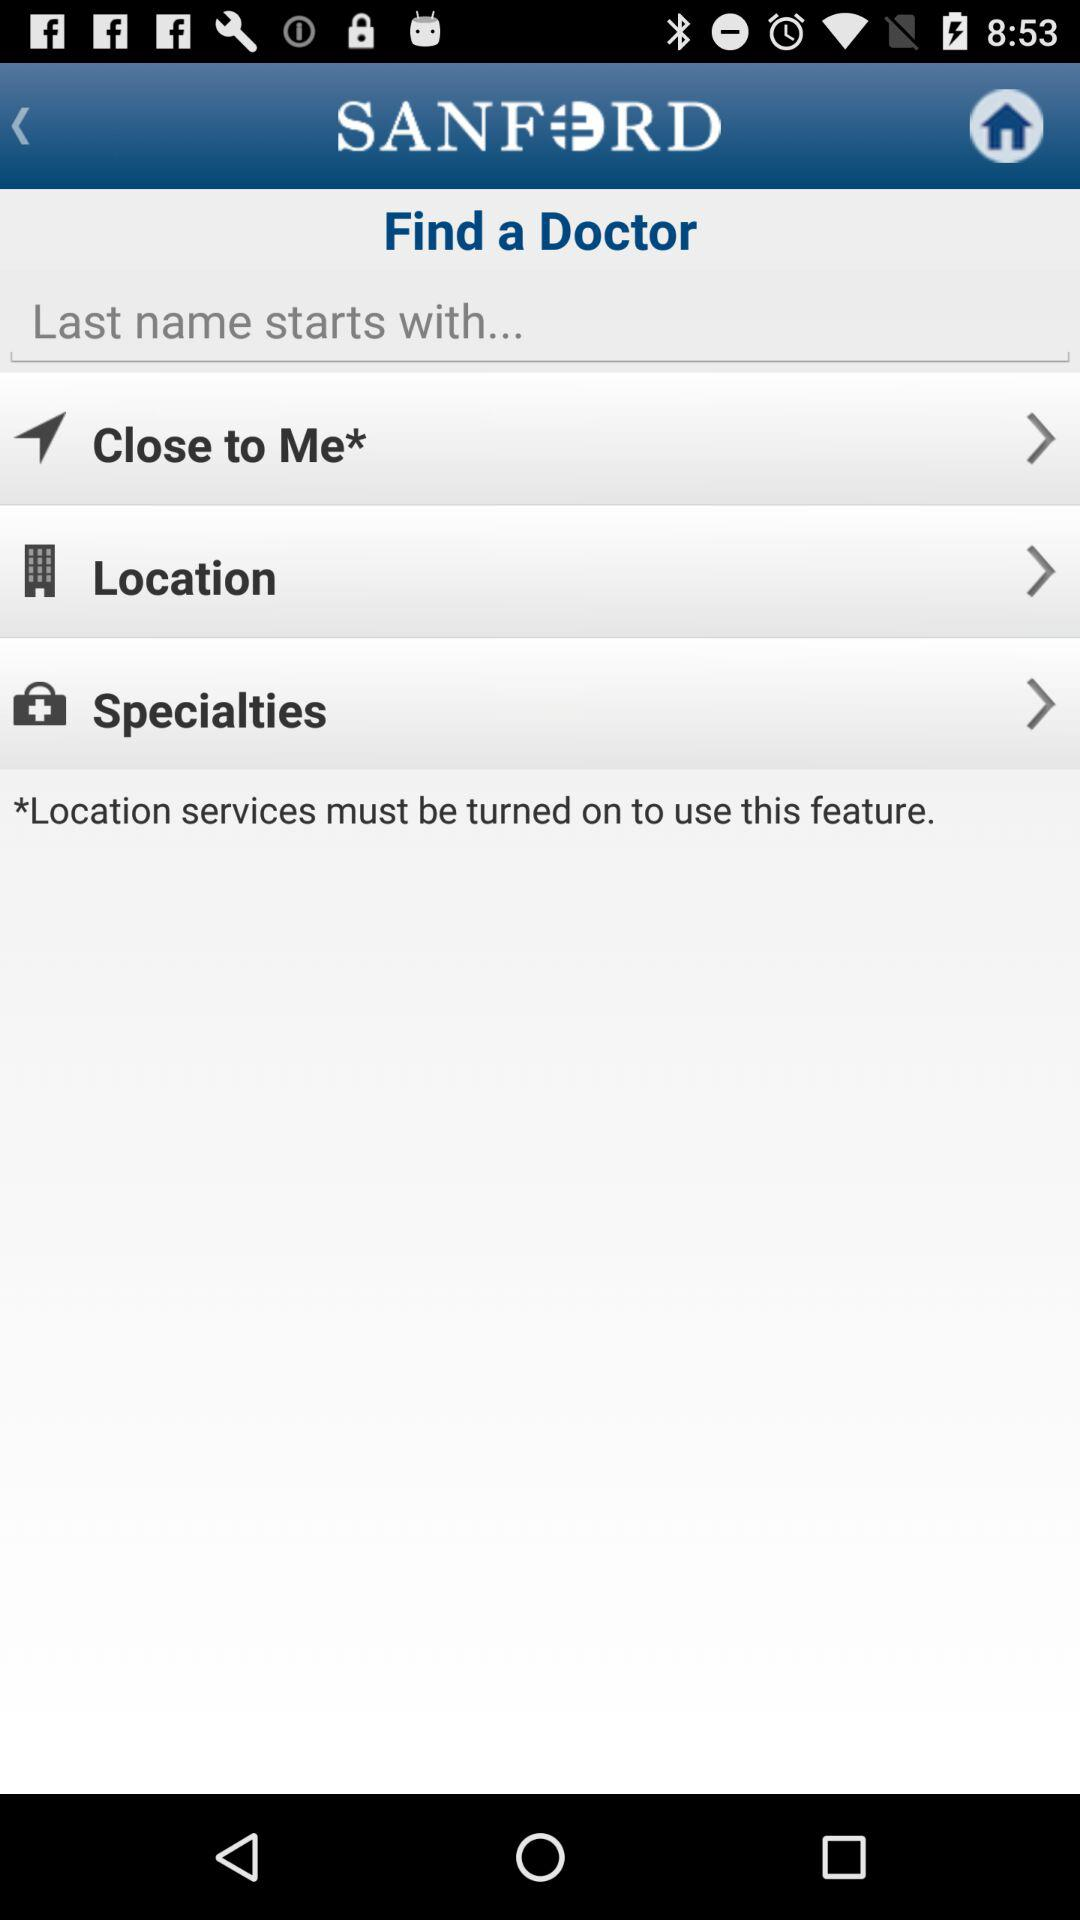What is the application name? The application name is "SANFORD". 